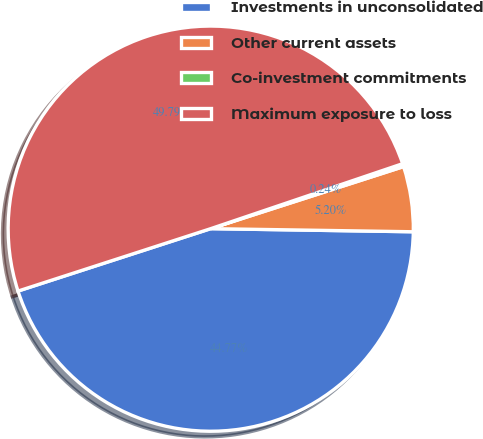<chart> <loc_0><loc_0><loc_500><loc_500><pie_chart><fcel>Investments in unconsolidated<fcel>Other current assets<fcel>Co-investment commitments<fcel>Maximum exposure to loss<nl><fcel>44.77%<fcel>5.2%<fcel>0.24%<fcel>49.79%<nl></chart> 